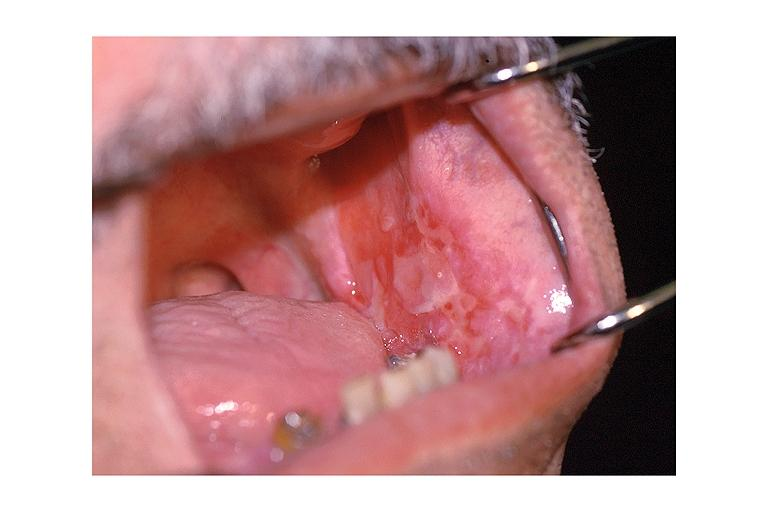does granulomata slide show cicatricial pemphigoid?
Answer the question using a single word or phrase. No 